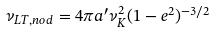<formula> <loc_0><loc_0><loc_500><loc_500>\nu _ { L T , n o d } = 4 \pi a ^ { \prime } \nu _ { K } ^ { 2 } ( 1 - e ^ { 2 } ) ^ { - 3 / 2 }</formula> 